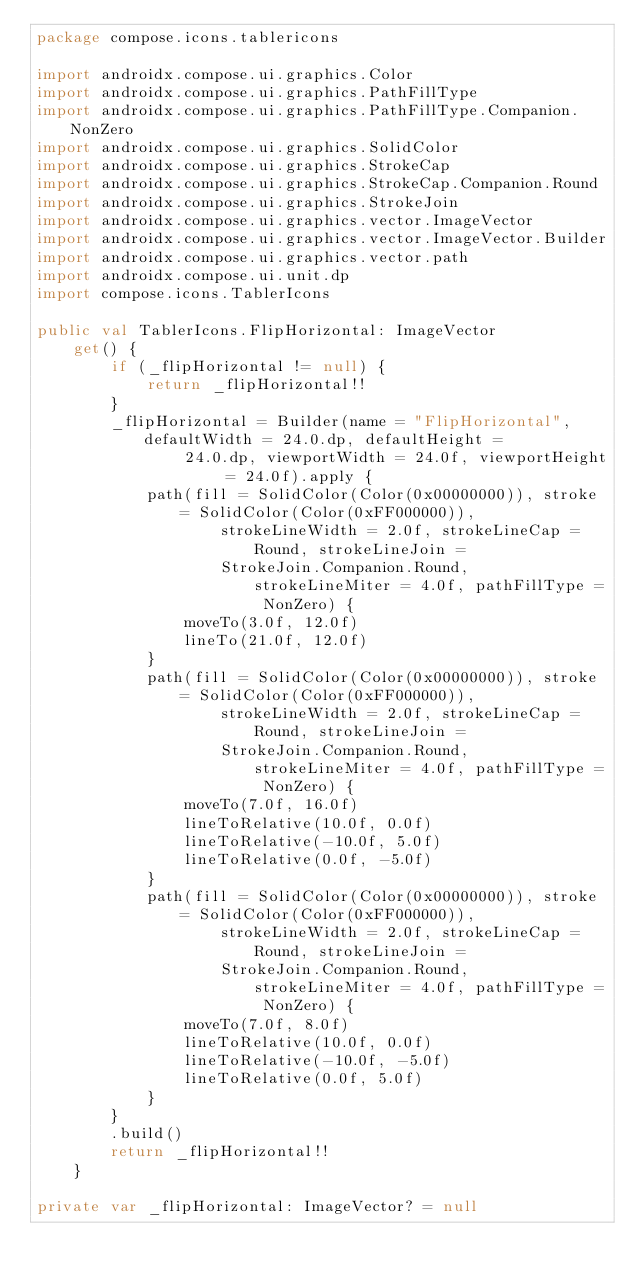Convert code to text. <code><loc_0><loc_0><loc_500><loc_500><_Kotlin_>package compose.icons.tablericons

import androidx.compose.ui.graphics.Color
import androidx.compose.ui.graphics.PathFillType
import androidx.compose.ui.graphics.PathFillType.Companion.NonZero
import androidx.compose.ui.graphics.SolidColor
import androidx.compose.ui.graphics.StrokeCap
import androidx.compose.ui.graphics.StrokeCap.Companion.Round
import androidx.compose.ui.graphics.StrokeJoin
import androidx.compose.ui.graphics.vector.ImageVector
import androidx.compose.ui.graphics.vector.ImageVector.Builder
import androidx.compose.ui.graphics.vector.path
import androidx.compose.ui.unit.dp
import compose.icons.TablerIcons

public val TablerIcons.FlipHorizontal: ImageVector
    get() {
        if (_flipHorizontal != null) {
            return _flipHorizontal!!
        }
        _flipHorizontal = Builder(name = "FlipHorizontal", defaultWidth = 24.0.dp, defaultHeight =
                24.0.dp, viewportWidth = 24.0f, viewportHeight = 24.0f).apply {
            path(fill = SolidColor(Color(0x00000000)), stroke = SolidColor(Color(0xFF000000)),
                    strokeLineWidth = 2.0f, strokeLineCap = Round, strokeLineJoin =
                    StrokeJoin.Companion.Round, strokeLineMiter = 4.0f, pathFillType = NonZero) {
                moveTo(3.0f, 12.0f)
                lineTo(21.0f, 12.0f)
            }
            path(fill = SolidColor(Color(0x00000000)), stroke = SolidColor(Color(0xFF000000)),
                    strokeLineWidth = 2.0f, strokeLineCap = Round, strokeLineJoin =
                    StrokeJoin.Companion.Round, strokeLineMiter = 4.0f, pathFillType = NonZero) {
                moveTo(7.0f, 16.0f)
                lineToRelative(10.0f, 0.0f)
                lineToRelative(-10.0f, 5.0f)
                lineToRelative(0.0f, -5.0f)
            }
            path(fill = SolidColor(Color(0x00000000)), stroke = SolidColor(Color(0xFF000000)),
                    strokeLineWidth = 2.0f, strokeLineCap = Round, strokeLineJoin =
                    StrokeJoin.Companion.Round, strokeLineMiter = 4.0f, pathFillType = NonZero) {
                moveTo(7.0f, 8.0f)
                lineToRelative(10.0f, 0.0f)
                lineToRelative(-10.0f, -5.0f)
                lineToRelative(0.0f, 5.0f)
            }
        }
        .build()
        return _flipHorizontal!!
    }

private var _flipHorizontal: ImageVector? = null
</code> 